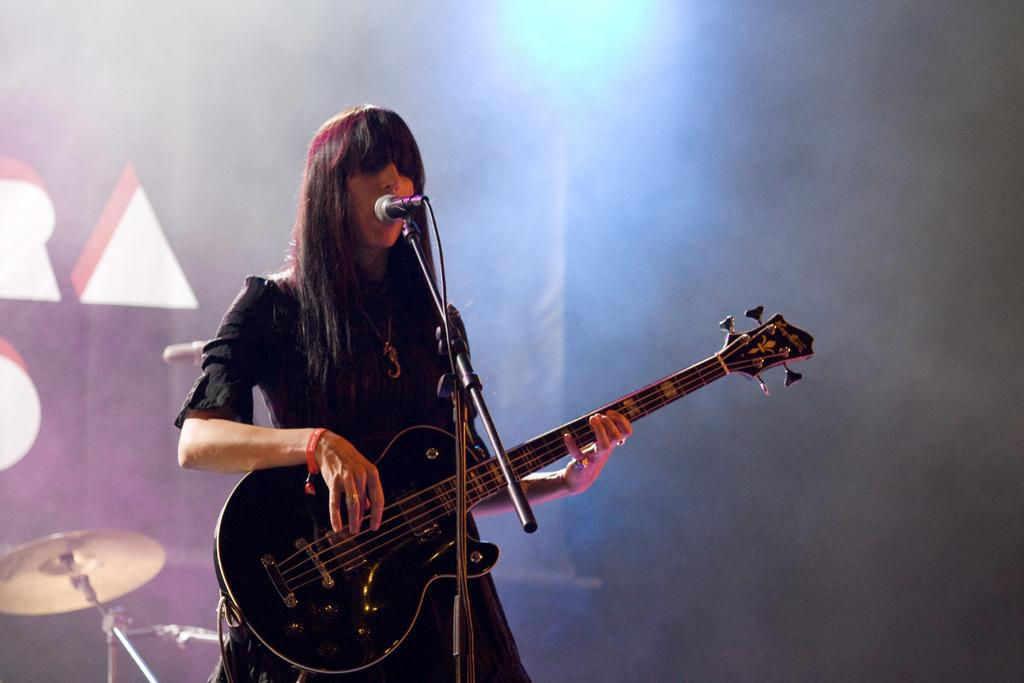What is the woman in the image doing? The woman is playing the guitar and singing. What is she wearing while performing? She is wearing a black dress. What can be seen in the background of the image? There is blue color light at the top of the image. Is the woman in the image teaching a class? There is no indication in the image that the woman is teaching a class. What type of stick is the woman using to play the guitar? The image does not show the woman using a stick to play the guitar; she is using her hands to strum the guitar strings. 